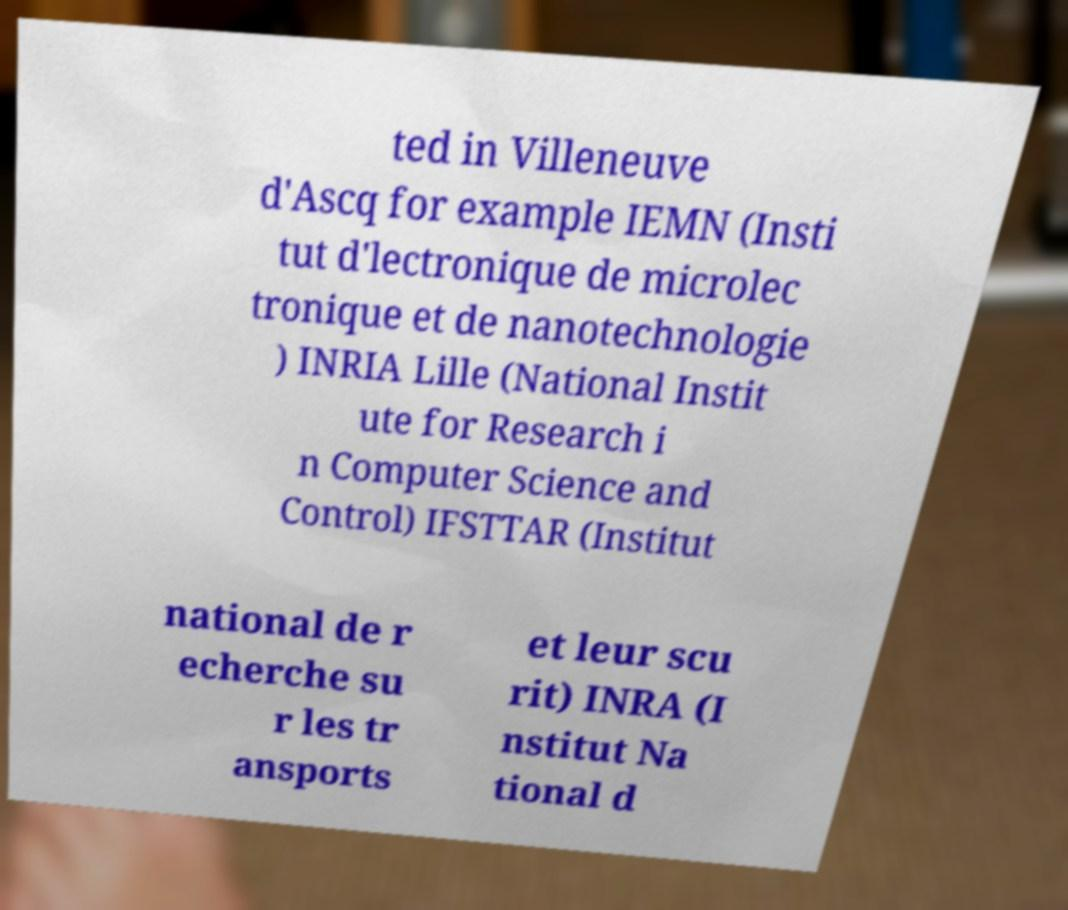Please read and relay the text visible in this image. What does it say? ted in Villeneuve d'Ascq for example IEMN (Insti tut d'lectronique de microlec tronique et de nanotechnologie ) INRIA Lille (National Instit ute for Research i n Computer Science and Control) IFSTTAR (Institut national de r echerche su r les tr ansports et leur scu rit) INRA (I nstitut Na tional d 